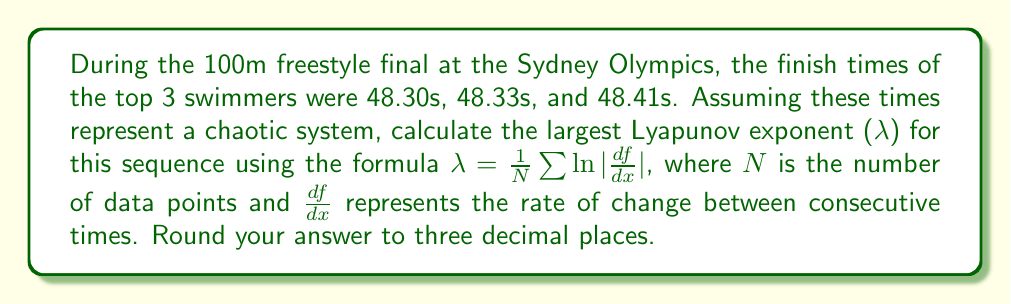Provide a solution to this math problem. To calculate the largest Lyapunov exponent for this swimming race finish time sequence, we'll follow these steps:

1. Identify the data points:
   t₁ = 48.30s, t₂ = 48.33s, t₃ = 48.41s

2. Calculate the differences between consecutive times:
   Δt₁ = t₂ - t₁ = 48.33 - 48.30 = 0.03s
   Δt₂ = t₃ - t₂ = 48.41 - 48.33 = 0.08s

3. Calculate |df/dx| for each interval:
   |df/dx₁| = |Δt₁/Δt| = |0.03/1| = 0.03
   |df/dx₂| = |Δt₂/Δt| = |0.08/1| = 0.08

4. Calculate ln|df/dx| for each interval:
   ln|df/dx₁| = ln(0.03) ≈ -3.5066
   ln|df/dx₂| = ln(0.08) ≈ -2.5257

5. Sum the ln|df/dx| values:
   Σ(ln|df/dx|) = -3.5066 + (-2.5257) = -6.0323

6. Apply the Lyapunov exponent formula:
   λ = (1/N) * Σ(ln|df/dx|)
   where N = 2 (number of intervals)

   λ = (1/2) * (-6.0323) ≈ -3.0162

7. Round the result to three decimal places:
   λ ≈ -3.016

The negative Lyapunov exponent indicates that the system is not chaotic but rather converging, which is expected in a well-controlled swimming race where athletes strive for consistent performance.
Answer: $$\lambda \approx -3.016$$ 